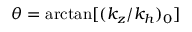Convert formula to latex. <formula><loc_0><loc_0><loc_500><loc_500>\theta = \arctan [ ( k _ { z } / k _ { h } ) _ { 0 } ]</formula> 